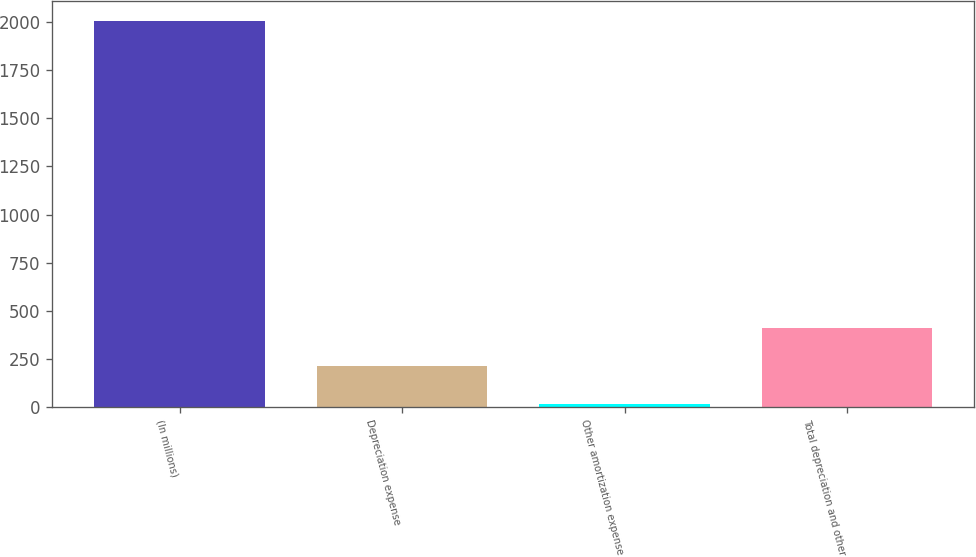<chart> <loc_0><loc_0><loc_500><loc_500><bar_chart><fcel>(In millions)<fcel>Depreciation expense<fcel>Other amortization expense<fcel>Total depreciation and other<nl><fcel>2007<fcel>213.3<fcel>14<fcel>412.6<nl></chart> 